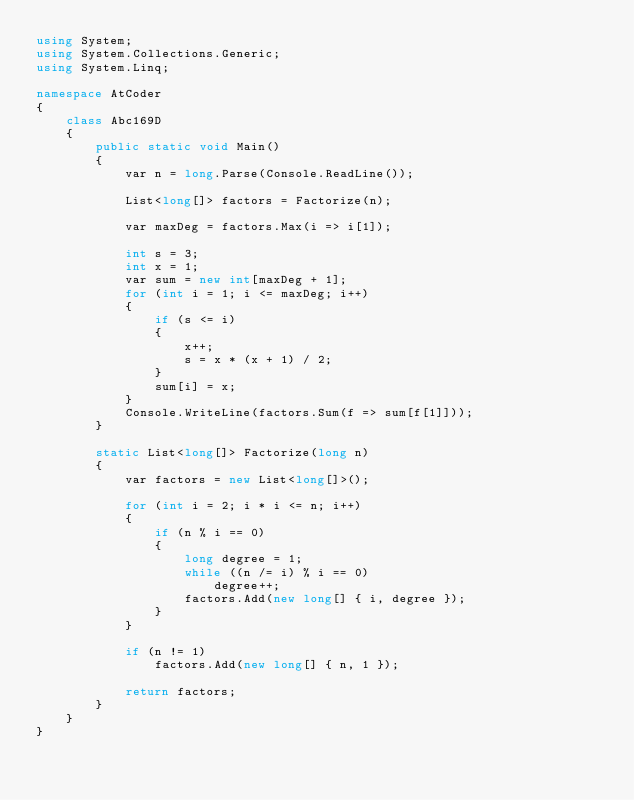Convert code to text. <code><loc_0><loc_0><loc_500><loc_500><_C#_>using System;
using System.Collections.Generic;
using System.Linq;

namespace AtCoder
{
    class Abc169D
    {
        public static void Main()
        {
            var n = long.Parse(Console.ReadLine());

            List<long[]> factors = Factorize(n);

            var maxDeg = factors.Max(i => i[1]);

            int s = 3;
            int x = 1;
            var sum = new int[maxDeg + 1];
            for (int i = 1; i <= maxDeg; i++)
            {
                if (s <= i)
                {
                    x++;
                    s = x * (x + 1) / 2;
                }
                sum[i] = x;
            }
            Console.WriteLine(factors.Sum(f => sum[f[1]]));
        }

        static List<long[]> Factorize(long n)
        {
            var factors = new List<long[]>();

            for (int i = 2; i * i <= n; i++)
            {
                if (n % i == 0)
                {
                    long degree = 1;
                    while ((n /= i) % i == 0)
                        degree++;
                    factors.Add(new long[] { i, degree });
                }
            }

            if (n != 1)
                factors.Add(new long[] { n, 1 });

            return factors;
        }
    }
}
</code> 